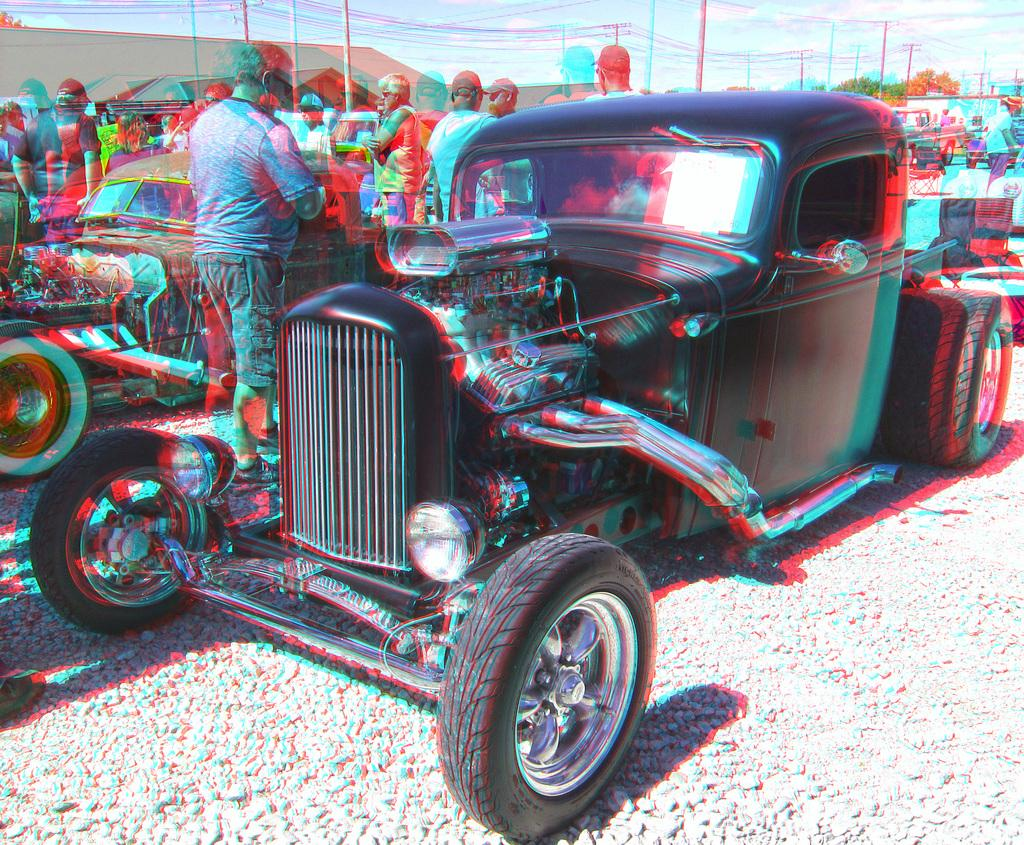What types of objects are on the ground in the image? There are vehicles on the ground in the image. What can be seen in the background of the image? There are tents, people, trees, and poles with wires in the background of the image. What type of fruit is hanging from the poles with wires in the image? There is no fruit, specifically quince, hanging from the poles with wires in the image. Are there any gloves visible in the image? There is no mention of gloves in the provided facts, and therefore no gloves can be seen in the image. 